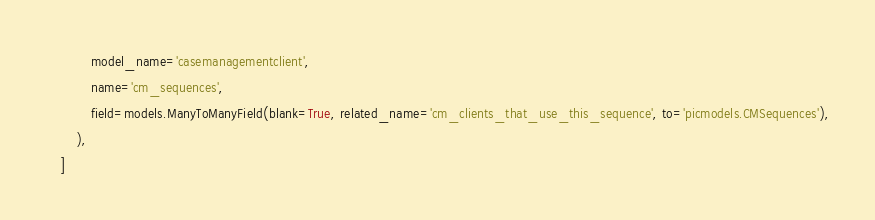Convert code to text. <code><loc_0><loc_0><loc_500><loc_500><_Python_>            model_name='casemanagementclient',
            name='cm_sequences',
            field=models.ManyToManyField(blank=True, related_name='cm_clients_that_use_this_sequence', to='picmodels.CMSequences'),
        ),
    ]
</code> 